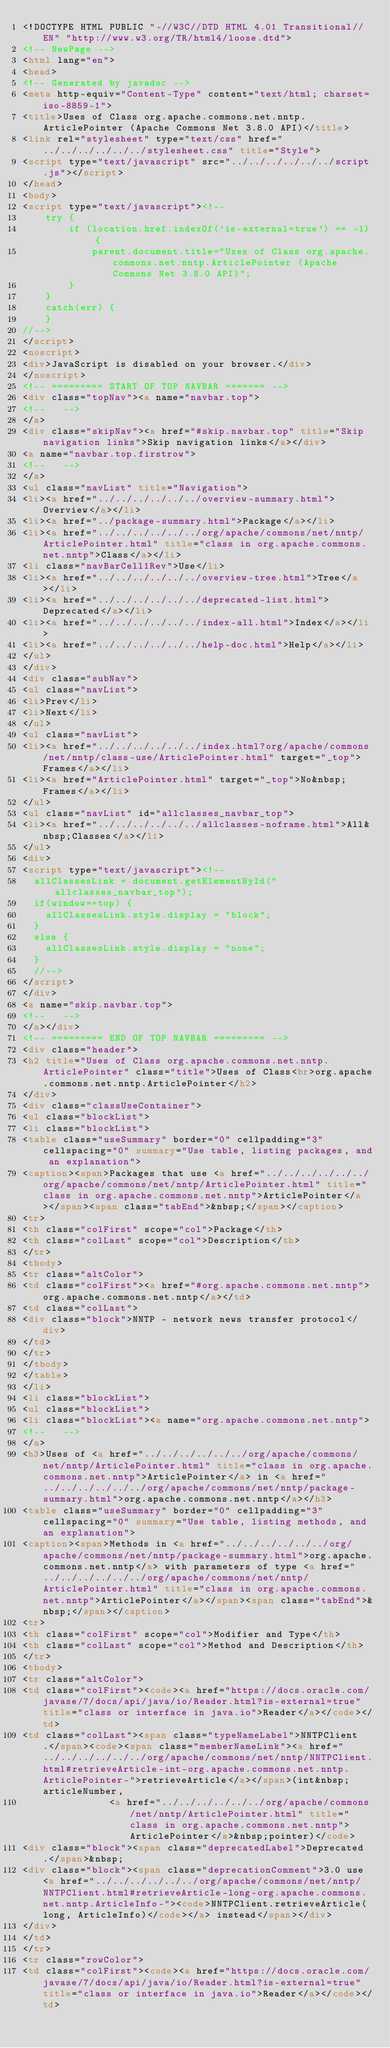Convert code to text. <code><loc_0><loc_0><loc_500><loc_500><_HTML_><!DOCTYPE HTML PUBLIC "-//W3C//DTD HTML 4.01 Transitional//EN" "http://www.w3.org/TR/html4/loose.dtd">
<!-- NewPage -->
<html lang="en">
<head>
<!-- Generated by javadoc -->
<meta http-equiv="Content-Type" content="text/html; charset=iso-8859-1">
<title>Uses of Class org.apache.commons.net.nntp.ArticlePointer (Apache Commons Net 3.8.0 API)</title>
<link rel="stylesheet" type="text/css" href="../../../../../../stylesheet.css" title="Style">
<script type="text/javascript" src="../../../../../../script.js"></script>
</head>
<body>
<script type="text/javascript"><!--
    try {
        if (location.href.indexOf('is-external=true') == -1) {
            parent.document.title="Uses of Class org.apache.commons.net.nntp.ArticlePointer (Apache Commons Net 3.8.0 API)";
        }
    }
    catch(err) {
    }
//-->
</script>
<noscript>
<div>JavaScript is disabled on your browser.</div>
</noscript>
<!-- ========= START OF TOP NAVBAR ======= -->
<div class="topNav"><a name="navbar.top">
<!--   -->
</a>
<div class="skipNav"><a href="#skip.navbar.top" title="Skip navigation links">Skip navigation links</a></div>
<a name="navbar.top.firstrow">
<!--   -->
</a>
<ul class="navList" title="Navigation">
<li><a href="../../../../../../overview-summary.html">Overview</a></li>
<li><a href="../package-summary.html">Package</a></li>
<li><a href="../../../../../../org/apache/commons/net/nntp/ArticlePointer.html" title="class in org.apache.commons.net.nntp">Class</a></li>
<li class="navBarCell1Rev">Use</li>
<li><a href="../../../../../../overview-tree.html">Tree</a></li>
<li><a href="../../../../../../deprecated-list.html">Deprecated</a></li>
<li><a href="../../../../../../index-all.html">Index</a></li>
<li><a href="../../../../../../help-doc.html">Help</a></li>
</ul>
</div>
<div class="subNav">
<ul class="navList">
<li>Prev</li>
<li>Next</li>
</ul>
<ul class="navList">
<li><a href="../../../../../../index.html?org/apache/commons/net/nntp/class-use/ArticlePointer.html" target="_top">Frames</a></li>
<li><a href="ArticlePointer.html" target="_top">No&nbsp;Frames</a></li>
</ul>
<ul class="navList" id="allclasses_navbar_top">
<li><a href="../../../../../../allclasses-noframe.html">All&nbsp;Classes</a></li>
</ul>
<div>
<script type="text/javascript"><!--
  allClassesLink = document.getElementById("allclasses_navbar_top");
  if(window==top) {
    allClassesLink.style.display = "block";
  }
  else {
    allClassesLink.style.display = "none";
  }
  //-->
</script>
</div>
<a name="skip.navbar.top">
<!--   -->
</a></div>
<!-- ========= END OF TOP NAVBAR ========= -->
<div class="header">
<h2 title="Uses of Class org.apache.commons.net.nntp.ArticlePointer" class="title">Uses of Class<br>org.apache.commons.net.nntp.ArticlePointer</h2>
</div>
<div class="classUseContainer">
<ul class="blockList">
<li class="blockList">
<table class="useSummary" border="0" cellpadding="3" cellspacing="0" summary="Use table, listing packages, and an explanation">
<caption><span>Packages that use <a href="../../../../../../org/apache/commons/net/nntp/ArticlePointer.html" title="class in org.apache.commons.net.nntp">ArticlePointer</a></span><span class="tabEnd">&nbsp;</span></caption>
<tr>
<th class="colFirst" scope="col">Package</th>
<th class="colLast" scope="col">Description</th>
</tr>
<tbody>
<tr class="altColor">
<td class="colFirst"><a href="#org.apache.commons.net.nntp">org.apache.commons.net.nntp</a></td>
<td class="colLast">
<div class="block">NNTP - network news transfer protocol</div>
</td>
</tr>
</tbody>
</table>
</li>
<li class="blockList">
<ul class="blockList">
<li class="blockList"><a name="org.apache.commons.net.nntp">
<!--   -->
</a>
<h3>Uses of <a href="../../../../../../org/apache/commons/net/nntp/ArticlePointer.html" title="class in org.apache.commons.net.nntp">ArticlePointer</a> in <a href="../../../../../../org/apache/commons/net/nntp/package-summary.html">org.apache.commons.net.nntp</a></h3>
<table class="useSummary" border="0" cellpadding="3" cellspacing="0" summary="Use table, listing methods, and an explanation">
<caption><span>Methods in <a href="../../../../../../org/apache/commons/net/nntp/package-summary.html">org.apache.commons.net.nntp</a> with parameters of type <a href="../../../../../../org/apache/commons/net/nntp/ArticlePointer.html" title="class in org.apache.commons.net.nntp">ArticlePointer</a></span><span class="tabEnd">&nbsp;</span></caption>
<tr>
<th class="colFirst" scope="col">Modifier and Type</th>
<th class="colLast" scope="col">Method and Description</th>
</tr>
<tbody>
<tr class="altColor">
<td class="colFirst"><code><a href="https://docs.oracle.com/javase/7/docs/api/java/io/Reader.html?is-external=true" title="class or interface in java.io">Reader</a></code></td>
<td class="colLast"><span class="typeNameLabel">NNTPClient.</span><code><span class="memberNameLink"><a href="../../../../../../org/apache/commons/net/nntp/NNTPClient.html#retrieveArticle-int-org.apache.commons.net.nntp.ArticlePointer-">retrieveArticle</a></span>(int&nbsp;articleNumber,
               <a href="../../../../../../org/apache/commons/net/nntp/ArticlePointer.html" title="class in org.apache.commons.net.nntp">ArticlePointer</a>&nbsp;pointer)</code>
<div class="block"><span class="deprecatedLabel">Deprecated.</span>&nbsp;
<div class="block"><span class="deprecationComment">3.0 use <a href="../../../../../../org/apache/commons/net/nntp/NNTPClient.html#retrieveArticle-long-org.apache.commons.net.nntp.ArticleInfo-"><code>NNTPClient.retrieveArticle(long, ArticleInfo)</code></a> instead</span></div>
</div>
</td>
</tr>
<tr class="rowColor">
<td class="colFirst"><code><a href="https://docs.oracle.com/javase/7/docs/api/java/io/Reader.html?is-external=true" title="class or interface in java.io">Reader</a></code></td></code> 